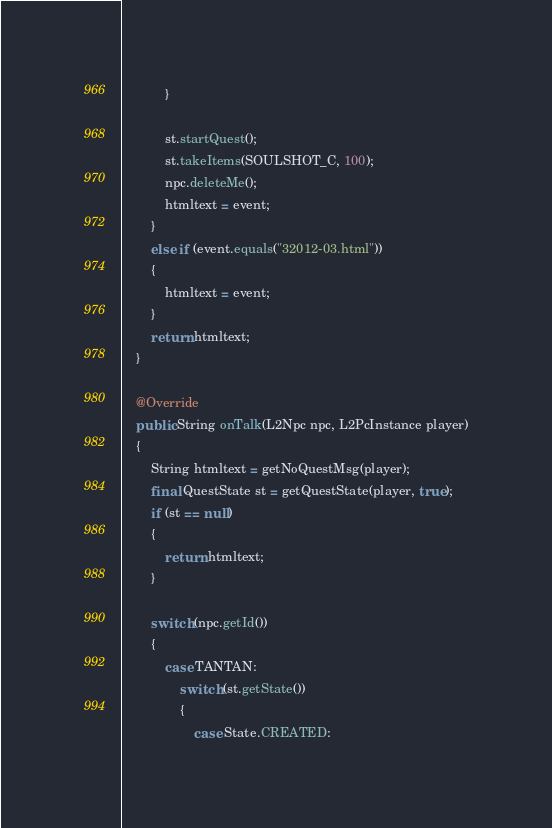Convert code to text. <code><loc_0><loc_0><loc_500><loc_500><_Java_>			}
			
			st.startQuest();
			st.takeItems(SOULSHOT_C, 100);
			npc.deleteMe();
			htmltext = event;
		}
		else if (event.equals("32012-03.html"))
		{
			htmltext = event;
		}
		return htmltext;
	}
	
	@Override
	public String onTalk(L2Npc npc, L2PcInstance player)
	{
		String htmltext = getNoQuestMsg(player);
		final QuestState st = getQuestState(player, true);
		if (st == null)
		{
			return htmltext;
		}
		
		switch (npc.getId())
		{
			case TANTAN:
				switch (st.getState())
				{
					case State.CREATED:</code> 